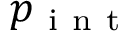<formula> <loc_0><loc_0><loc_500><loc_500>p _ { i n t }</formula> 